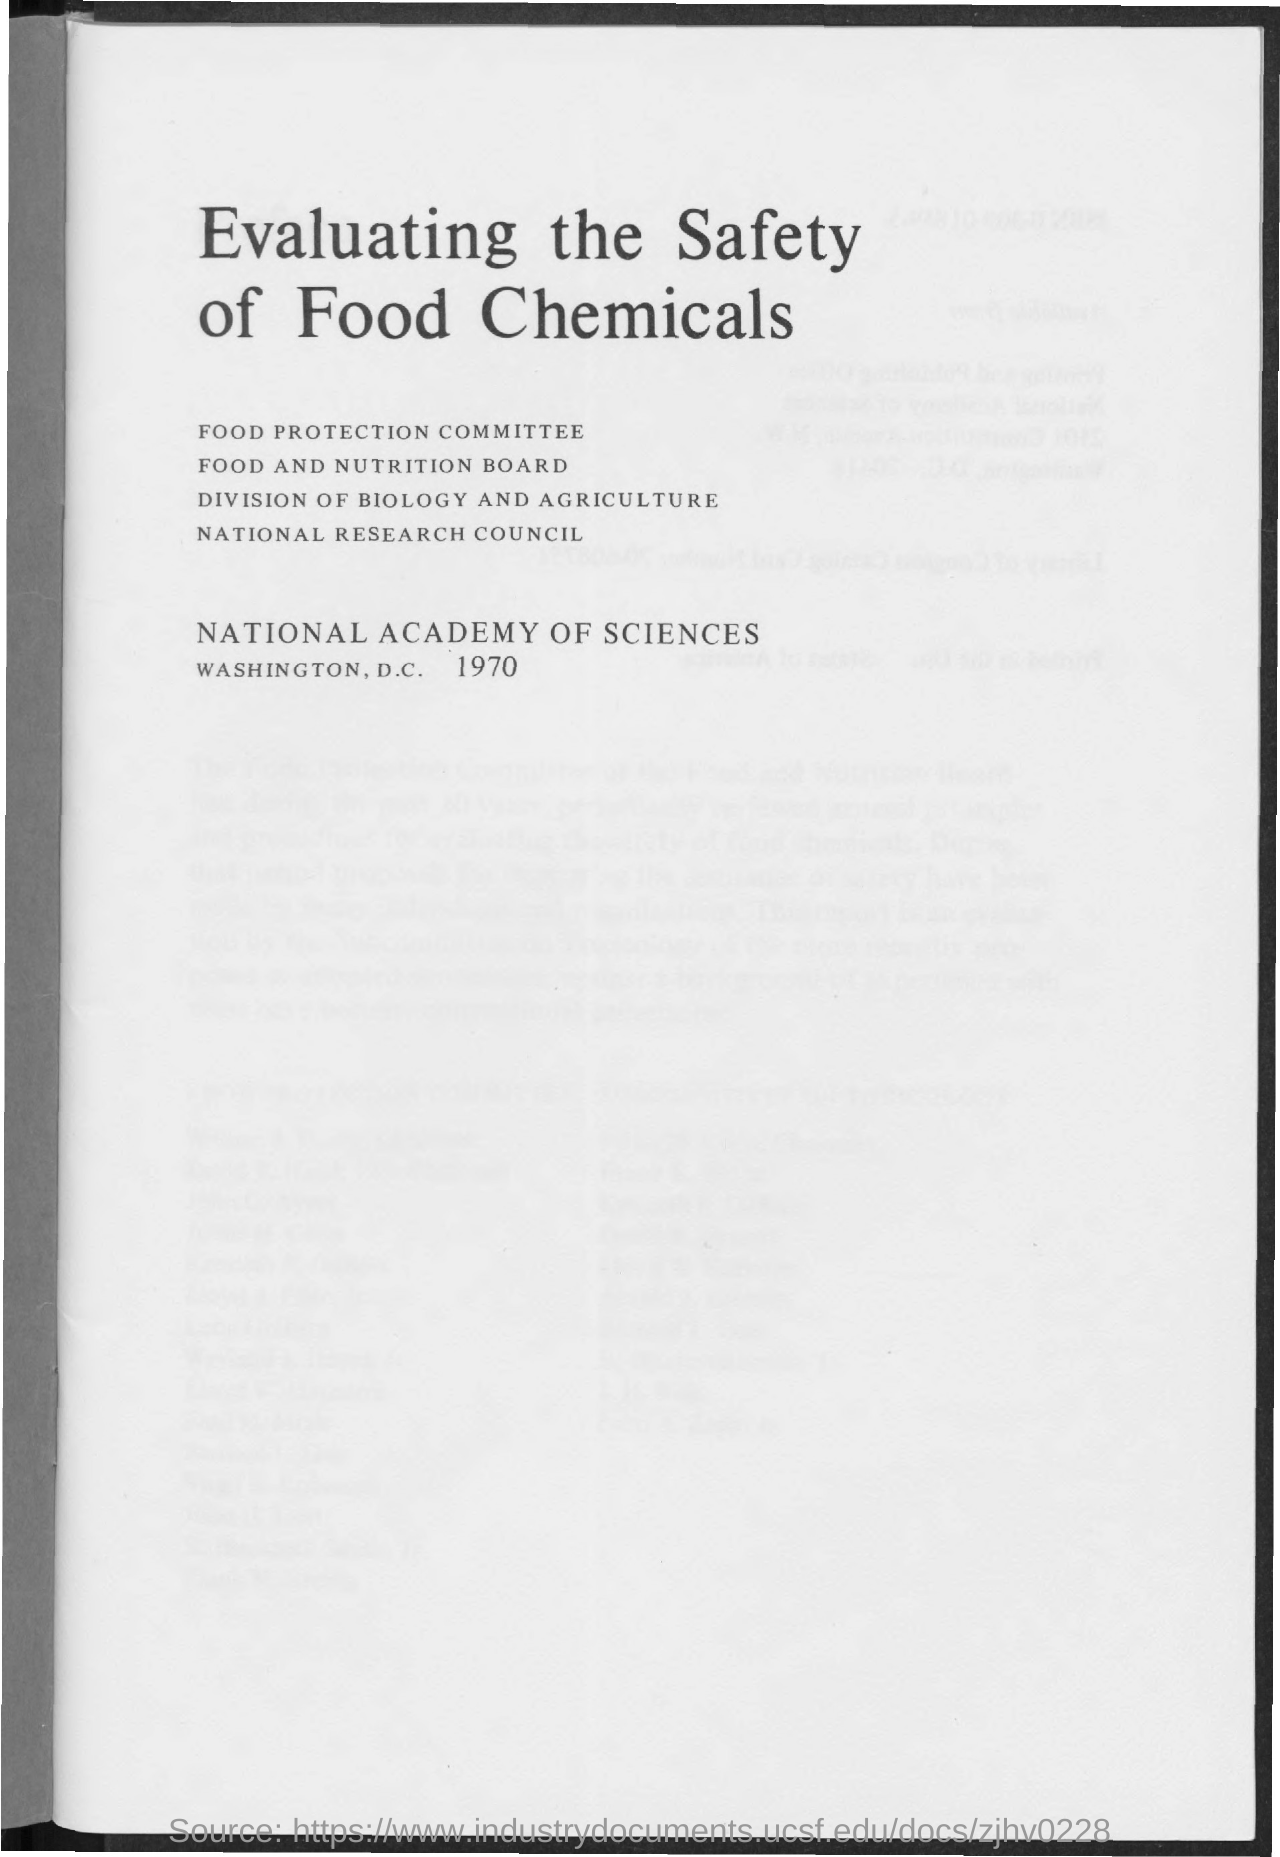What is the title of the document? The title of the document is 'Evaluating the Safety of Food Chemicals.' Can you tell me more about what the document might cover? Based on the title, the document likely discusses methods, criteria, and findings related to the assessment of health risks posed by various chemicals used in food products. Such a report would be useful for policymakers, researchers, and industry stakeholders interested in food safety. 